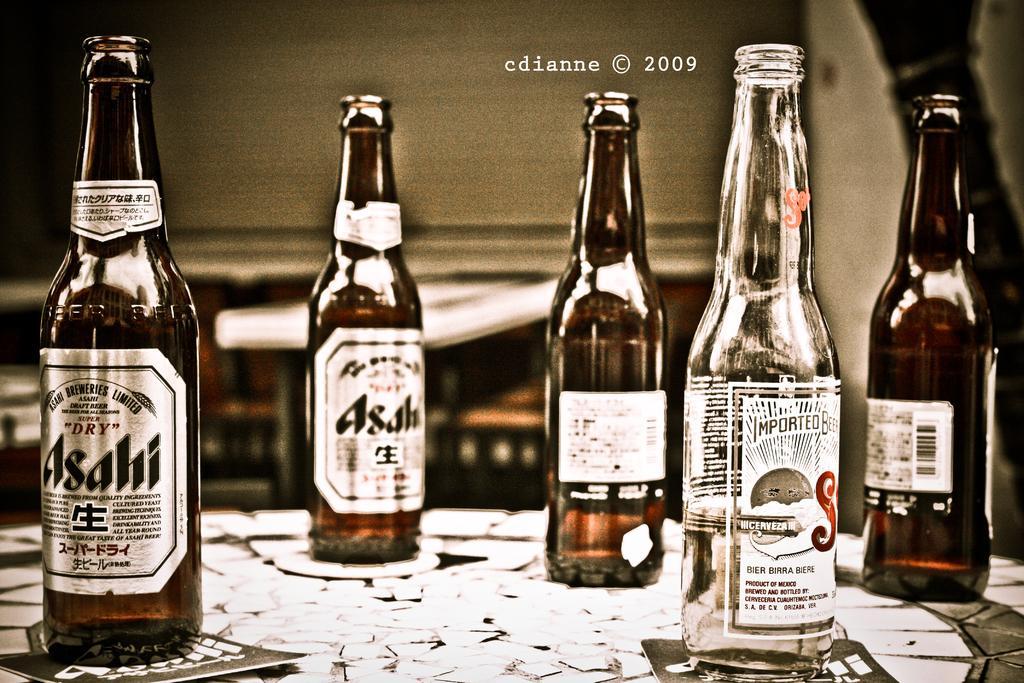Could you give a brief overview of what you see in this image? There are many bottles. These bottles are on a table. On the bottle there are logos. 